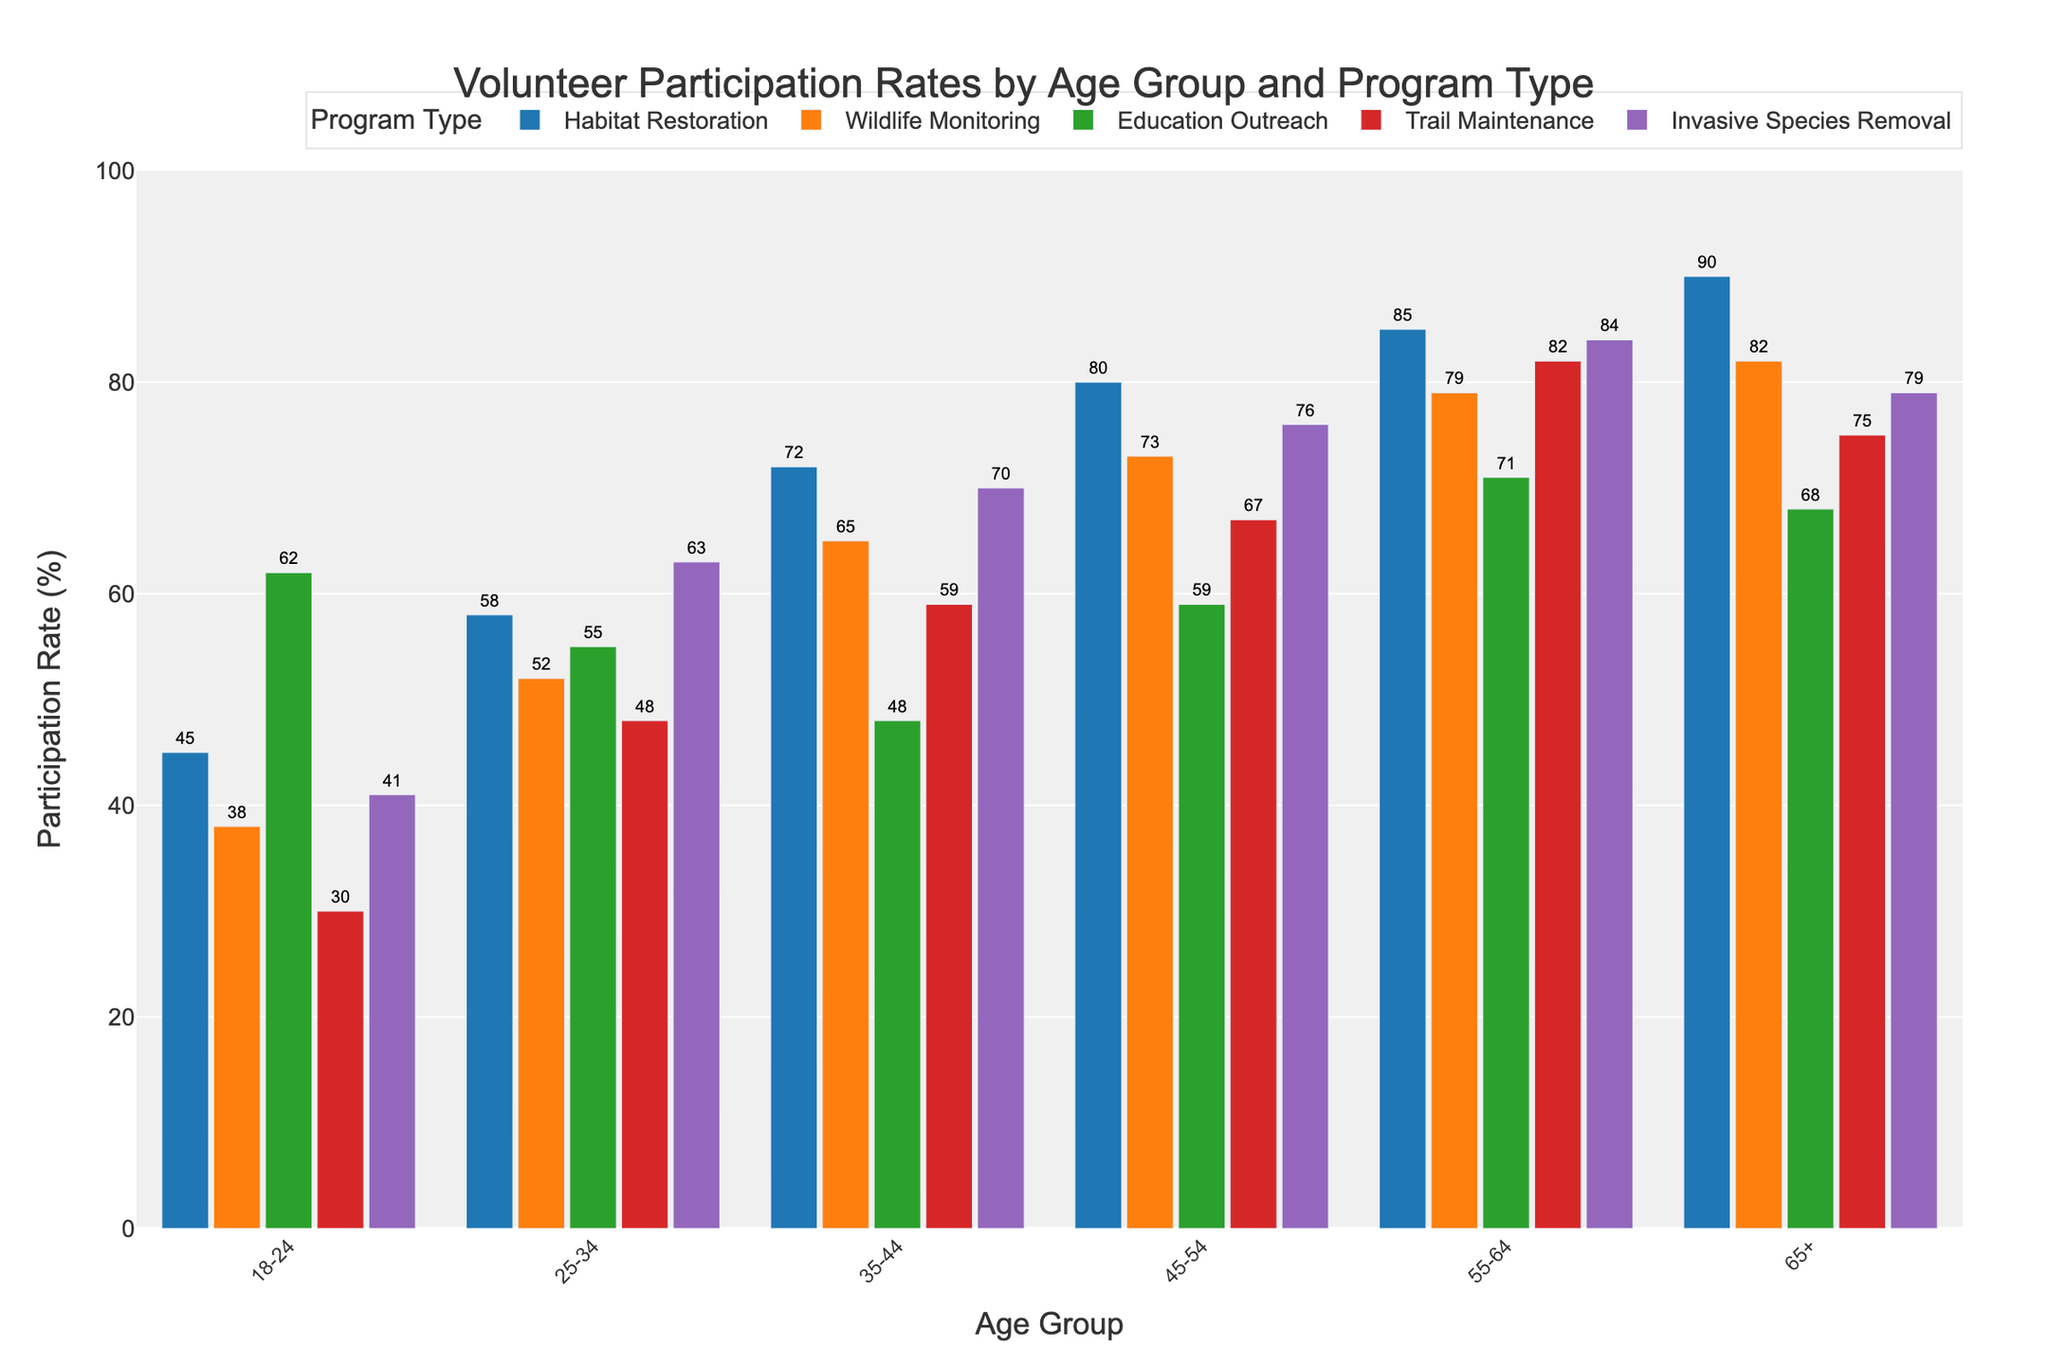What is the participation rate for Habitat Restoration in the 55-64 age group? Locate the bar for Habitat Restoration within the 55-64 age group. Read the height of the bar which is the participation rate.
Answer: 85 Which age group has the lowest participation rate in Wildlife Monitoring? Identify the bars for Wildlife Monitoring across all age groups. Compare their heights to find the shortest bar, which indicates the lowest participation rate.
Answer: 18-24 Among the 25-34 and 35-44 age groups, which has a higher participation rate in Invasive Species Removal? Compare the heights of the bars for Invasive Species Removal for the 25-34 and 35-44 age groups. Determine which bar is taller.
Answer: 35-44 What is the total participation rate for the 45-54 age group across all program types? Add the heights of the bars for all program types in the 45-54 age group: Habitat Restoration (80), Wildlife Monitoring (73), Education Outreach (59), Trail Maintenance (67), and Invasive Species Removal (76). Total = 80 + 73 + 59 + 67 + 76.
Answer: 355 For which program type is the participation rate the highest in the 65+ age group? Identify the bars for all program types in the 65+ age group. Determine which bar is the tallest.
Answer: Habitat Restoration By how much does the participation rate in Education Outreach increase from the 18-24 to the 55-64 age group? Subtract the participation rate of the 18-24 age group in Education Outreach (62) from the participation rate of the 55-64 age group (71): 71 - 62.
Answer: 9 Which program type has the smallest variation in participation rates across age groups? Calculate the range (difference between the highest and lowest rates) for each program type across age groups. Compare these ranges to find the smallest one.
Answer: Education Outreach What is the average participation rate in Trail Maintenance across all age groups? Add the participation rates for Trail Maintenance across all age groups (30, 48, 59, 67, 82, 75). Then divide by the number of age groups (6): (30 + 48 + 59 + 67 + 82 + 75) / 6.
Answer: 60.17 